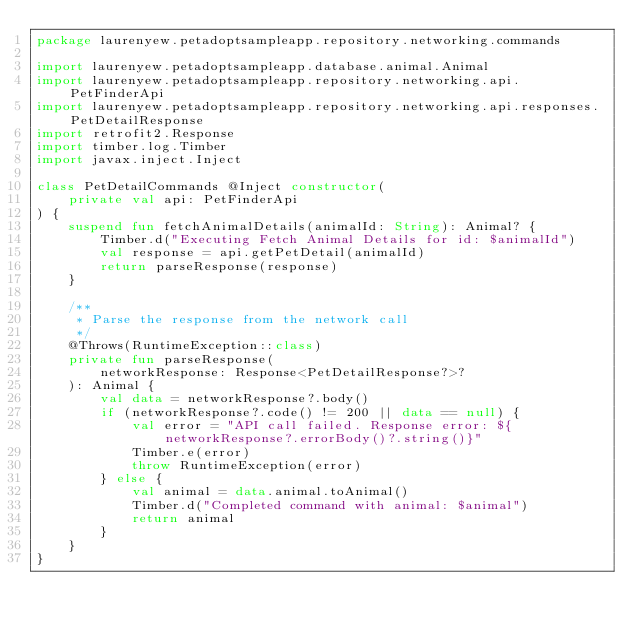<code> <loc_0><loc_0><loc_500><loc_500><_Kotlin_>package laurenyew.petadoptsampleapp.repository.networking.commands

import laurenyew.petadoptsampleapp.database.animal.Animal
import laurenyew.petadoptsampleapp.repository.networking.api.PetFinderApi
import laurenyew.petadoptsampleapp.repository.networking.api.responses.PetDetailResponse
import retrofit2.Response
import timber.log.Timber
import javax.inject.Inject

class PetDetailCommands @Inject constructor(
    private val api: PetFinderApi
) {
    suspend fun fetchAnimalDetails(animalId: String): Animal? {
        Timber.d("Executing Fetch Animal Details for id: $animalId")
        val response = api.getPetDetail(animalId)
        return parseResponse(response)
    }

    /**
     * Parse the response from the network call
     */
    @Throws(RuntimeException::class)
    private fun parseResponse(
        networkResponse: Response<PetDetailResponse?>?
    ): Animal {
        val data = networkResponse?.body()
        if (networkResponse?.code() != 200 || data == null) {
            val error = "API call failed. Response error: ${networkResponse?.errorBody()?.string()}"
            Timber.e(error)
            throw RuntimeException(error)
        } else {
            val animal = data.animal.toAnimal()
            Timber.d("Completed command with animal: $animal")
            return animal
        }
    }
}</code> 